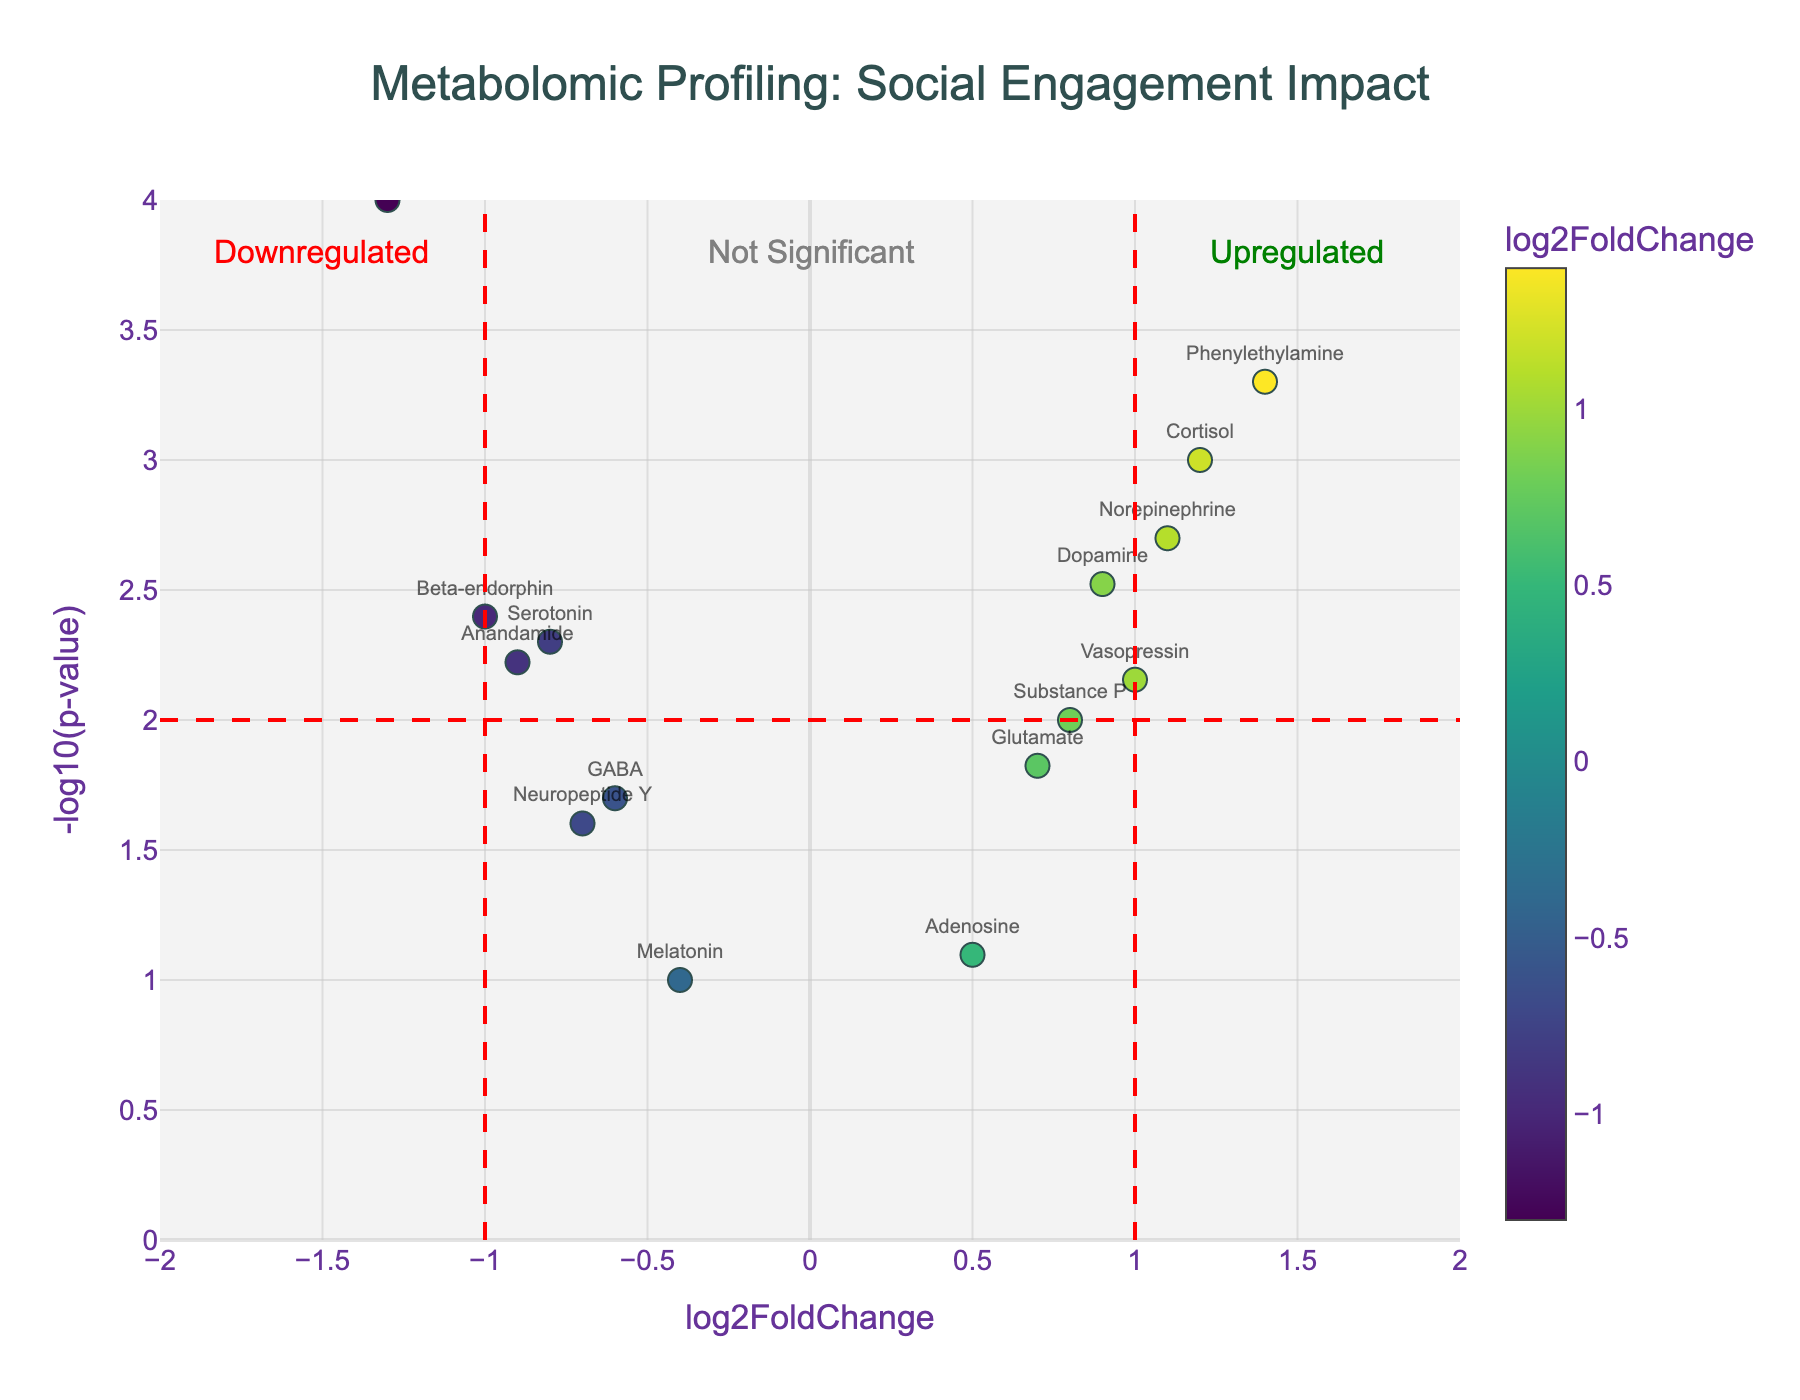What's the title of the figure? The title is usually positioned at the top of the plot for easy identification. In this case, it's specified under the layout settings for the figure.
Answer: Metabolomic Profiling: Social Engagement Impact What does the x-axis represent? The x-axis typically represents the fold change in a Volcano Plot, which shows how much each metabolite's expression level changes. In this figure, it's labeled as "log2FoldChange."
Answer: log2FoldChange What does the y-axis represent? The y-axis represents the significance of the change in expression levels, often shown as the negative logarithm of the p-value. Here, it's labeled as "-log10(p-value)."
Answer: -log10(p-value) Which metabolite has the highest -log10(pvalue)? By examining the scatter plot, you can see that the point highest on the y-axis corresponds to the metabolite with the lowest p-value.
Answer: Oxytocin How many metabolites are upregulated? Upregulated metabolites will have positive values on the x-axis (right side of the vertical threshold line at x=1). Count these data points.
Answer: 8 How many metabolites are down-regulated but not significant? Down-regulated metabolites will have negative x-axis values (left side). To be not significant, their x values must be greater than -1. Count these data points.
Answer: 2 Which metabolite associated with stress has the highest log2FoldChange? Metabolites related to stress are cortisol, norepinephrine, and others. Comparing their positions on the x-axis selects the one furthest to the right.
Answer: Phenylethylamine Between Serotonin and Dopamine, which has a more significant p-value? Compare their positions on the y-axis. The one lower down has a higher p-value.
Answer: Serotonin Among the metabolites with -log10(p-value) greater than 2, how many are down-regulated? Identify which data points with a y-axis value above 2 have negative x-axis values. Count these points.
Answer: 3 Which metabolite with a log2FoldChange less than -1 has the most significant p-value? Focus on metabolites left of x=-1 and compare their y-axis values to find the highest point.
Answer: Oxytocin 